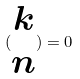Convert formula to latex. <formula><loc_0><loc_0><loc_500><loc_500>( \begin{matrix} k \\ n \end{matrix} ) = 0</formula> 